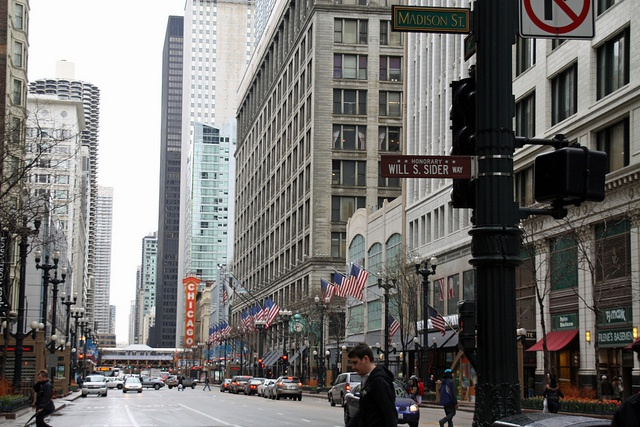Describe the objects in this image and their specific colors. I can see traffic light in brown, black, gray, darkgray, and lightgray tones, people in brown, black, maroon, and gray tones, traffic light in brown, black, gray, darkgray, and lightgray tones, people in brown, black, maroon, and gray tones, and people in brown, black, gray, maroon, and navy tones in this image. 